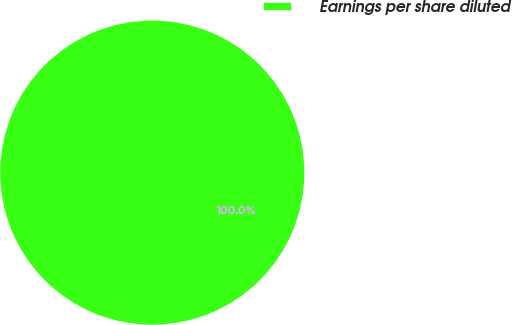<chart> <loc_0><loc_0><loc_500><loc_500><pie_chart><fcel>Earnings per share diluted<nl><fcel>100.0%<nl></chart> 